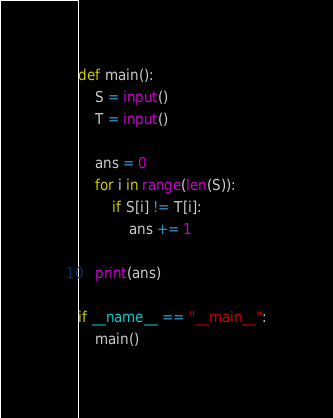Convert code to text. <code><loc_0><loc_0><loc_500><loc_500><_Python_>def main():
    S = input()
    T = input()

    ans = 0
    for i in range(len(S)):
        if S[i] != T[i]:
            ans += 1

    print(ans)
    
if __name__ == "__main__":
    main()</code> 